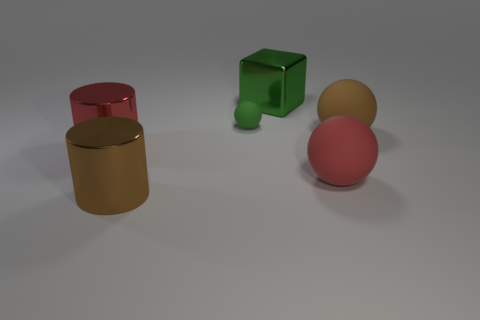Add 4 big brown matte balls. How many objects exist? 10 Subtract all cubes. How many objects are left? 5 Subtract 1 green spheres. How many objects are left? 5 Subtract all brown matte things. Subtract all red balls. How many objects are left? 4 Add 2 brown things. How many brown things are left? 4 Add 4 small shiny cubes. How many small shiny cubes exist? 4 